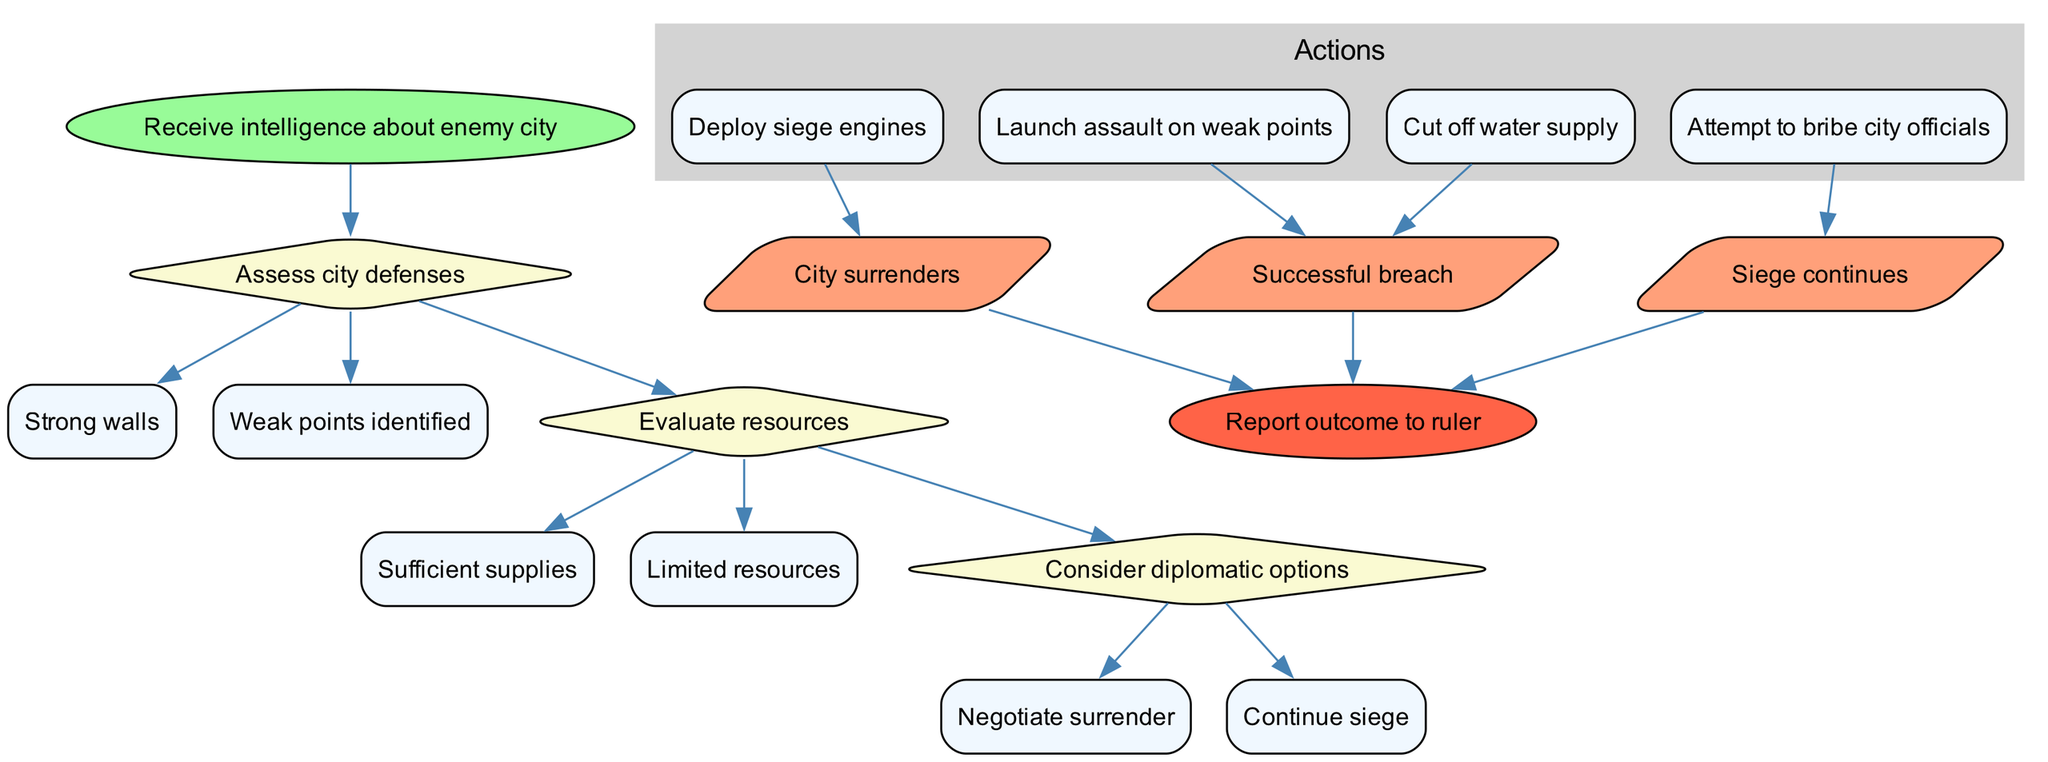What is the starting point of the decision-making process? The starting point is indicated as "Receive intelligence about enemy city" in the diagram.
Answer: Receive intelligence about enemy city How many decisions are depicted in the diagram? The diagram presents three decisions: Assess city defenses, Evaluate resources, and Consider diplomatic options.
Answer: 3 What are the options available under the decision "Evaluate resources"? The options listed under "Evaluate resources" are "Sufficient supplies" and "Limited resources”.
Answer: Sufficient supplies, Limited resources What action is taken if the option "Weak points identified" is chosen? Following the identification of weak points, the action that can be taken is "Launch assault on weak points". This is an action occurring after the decision.
Answer: Launch assault on weak points If the commander decides to "Negotiate surrender," what is the potential outcome? The potential outcome for negotiating surrender can lead to the city surrendering, as indicated in the relationships described in the diagram.
Answer: City surrenders Which options follow the decision "Consider diplomatic options"? The two options following "Consider diplomatic options" are "Negotiate surrender" and "Continue siege."
Answer: Negotiate surrender, Continue siege How many actions are listed in total in the diagram? There are four actions listed in the diagram: Deploy siege engines, Cut off water supply, Attempt to bribe city officials, and Launch assault on weak points.
Answer: 4 What type of node represents the final outcome in the diagram? The final outcome is represented by a parallelogram node, which indicates results of the actions taken during the siege.
Answer: Parallelogram If the commander decides to deploy siege engines, what is one possible outcome of this action? One possible outcome of deploying siege engines is "Successful breach," as indicated in the diagram following that action.
Answer: Successful breach 